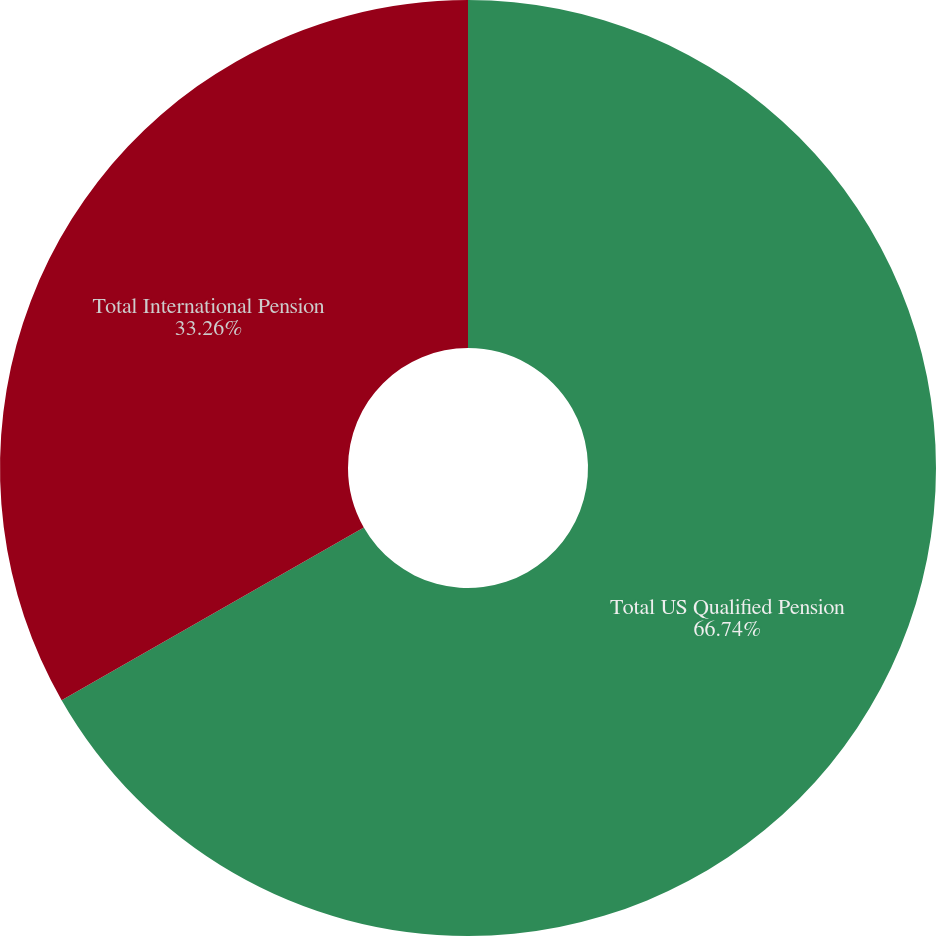Convert chart. <chart><loc_0><loc_0><loc_500><loc_500><pie_chart><fcel>Total US Qualified Pension<fcel>Total International Pension<nl><fcel>66.74%<fcel>33.26%<nl></chart> 